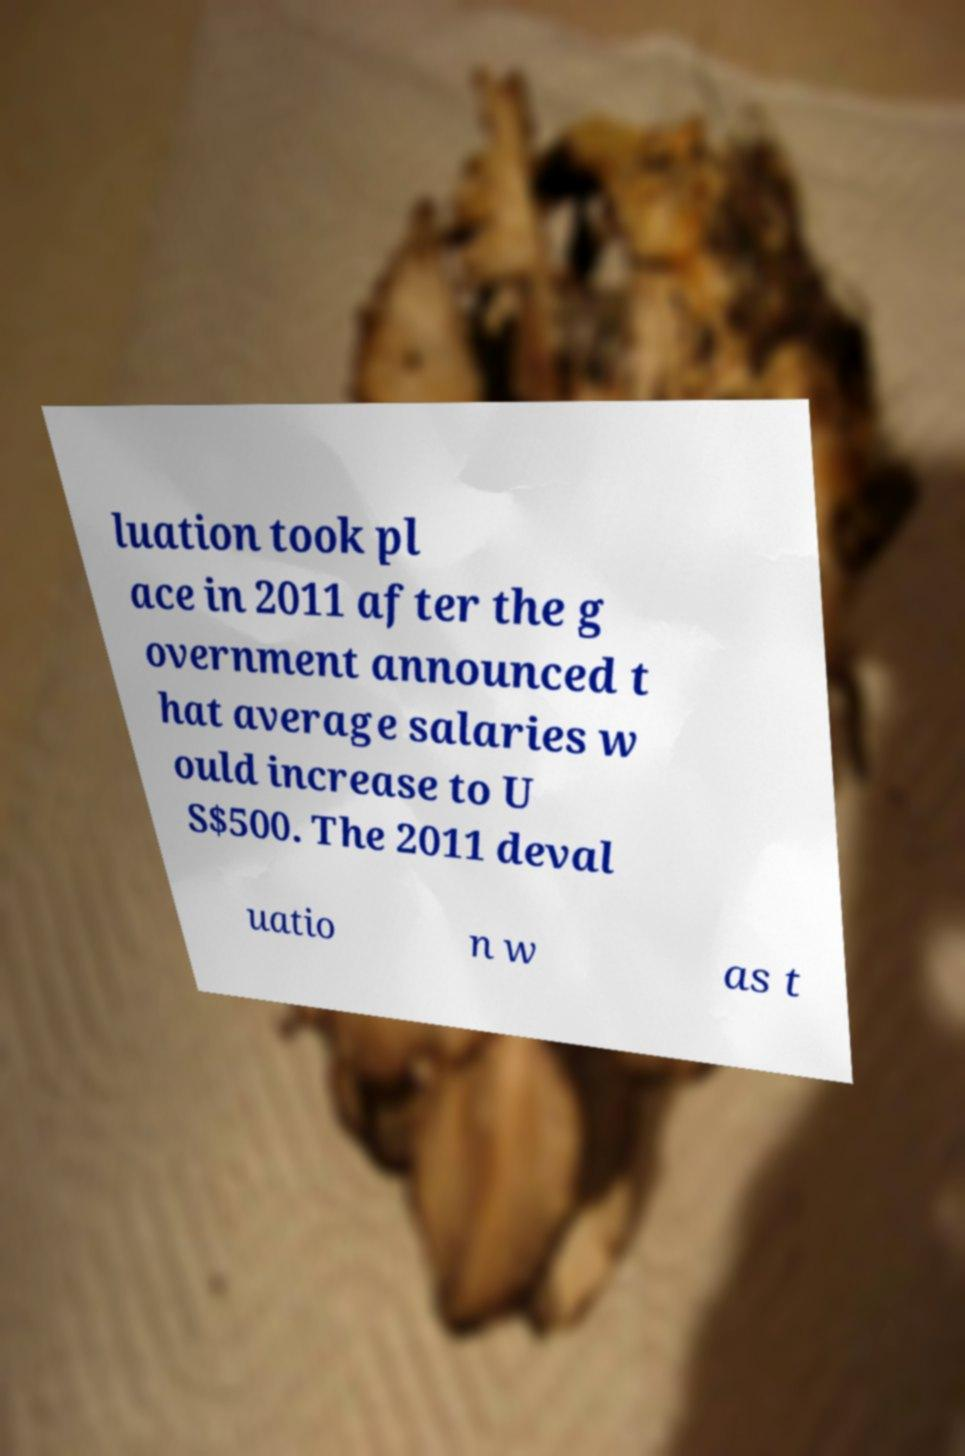Please read and relay the text visible in this image. What does it say? luation took pl ace in 2011 after the g overnment announced t hat average salaries w ould increase to U S$500. The 2011 deval uatio n w as t 